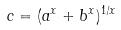<formula> <loc_0><loc_0><loc_500><loc_500>c = ( a ^ { x } + b ^ { x } ) ^ { 1 / x }</formula> 